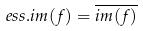<formula> <loc_0><loc_0><loc_500><loc_500>e s s . i m ( f ) = \overline { i m ( f ) }</formula> 